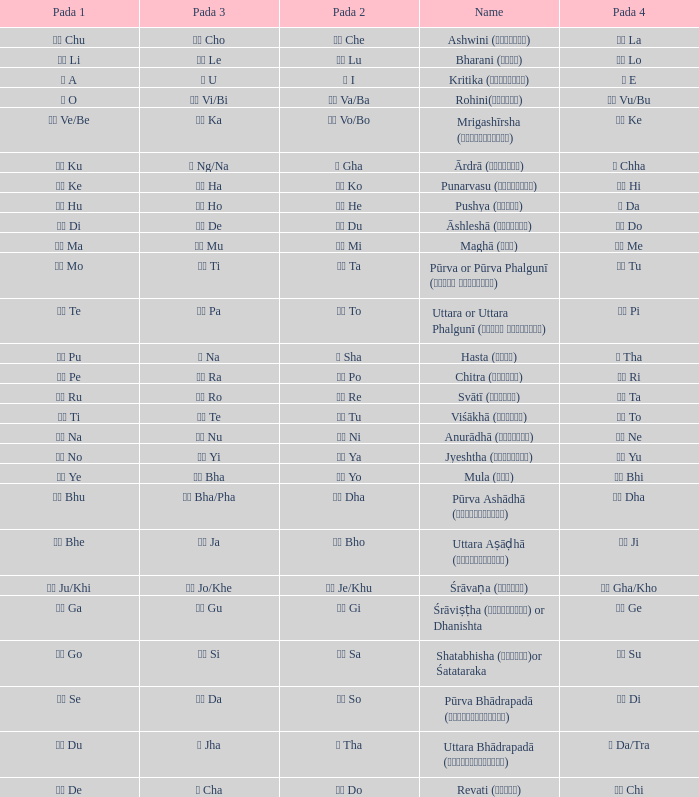Which Pada 3 has a Pada 1 of टे te? पा Pa. 